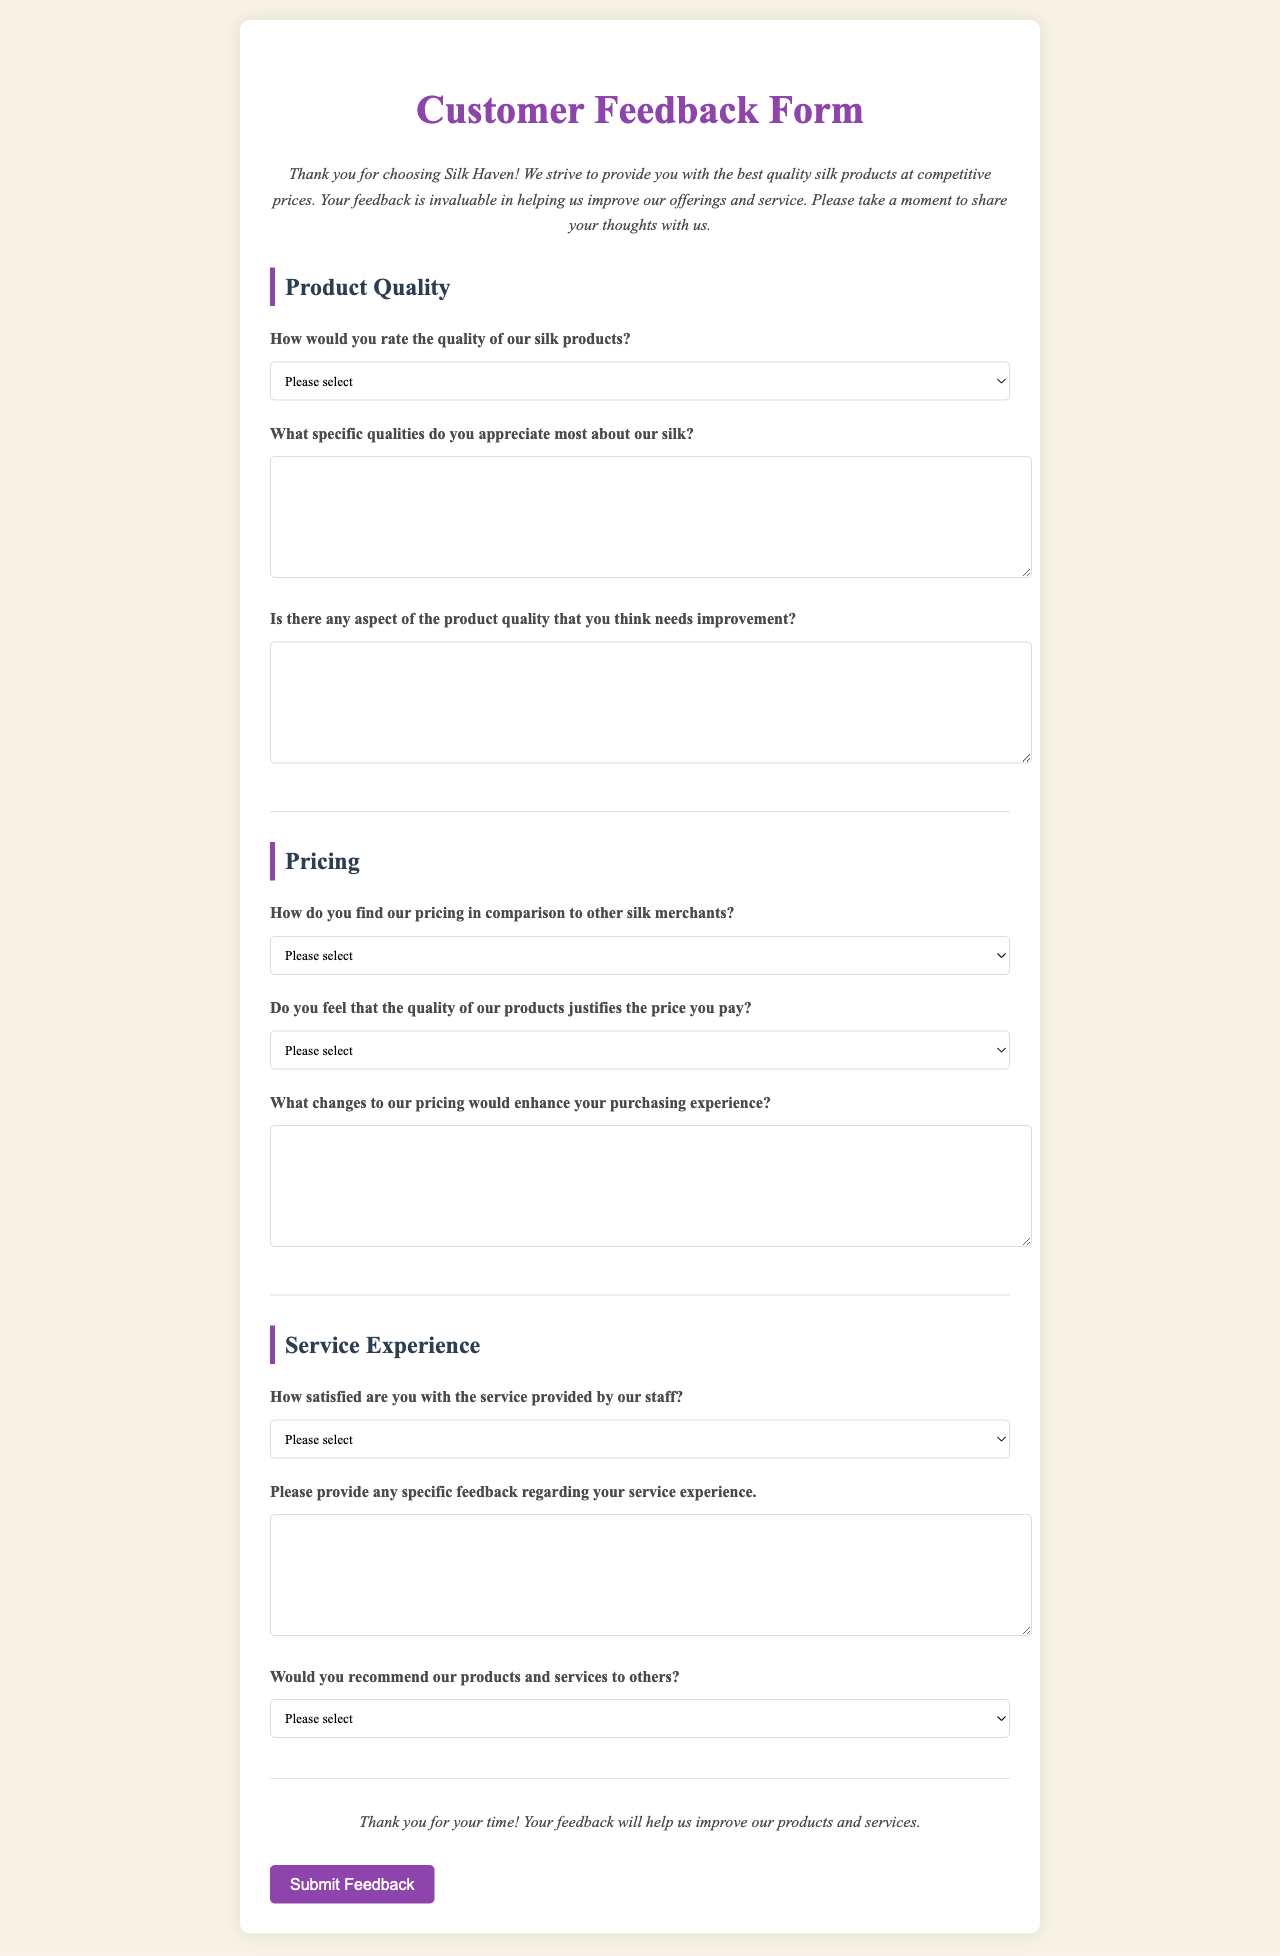What is the title of the document? The title of the document is indicated in the <title> tag within the HTML, which is "Silk Haven Customer Feedback."
Answer: Silk Haven Customer Feedback How many sections are there in the form? The sections are defined by the <div> tags with the class "section," and there are three sections: Product Quality, Pricing, and Service Experience.
Answer: 3 What does the "intro" paragraph thank customers for? The "intro" paragraph expresses gratitude for choosing Silk Haven and emphasizes the importance of customer feedback.
Answer: Choosing Silk Haven Which option is available for rating product quality? The options are provided in a <select> dropdown for rating product quality, which includes "Excellent," "Good," "Average," and "Poor."
Answer: Excellent, Good, Average, Poor How should a customer express their thoughts on pricing changes? Customers are prompted to describe their thoughts on pricing changes in a text area labeled "What changes to our pricing would enhance your purchasing experience?"
Answer: Text area for suggestions What is the purpose of the feedback form? The document clearly indicates that the purpose of the feedback form is to gather insights to improve products and services.
Answer: Improve products and services What color is the background of the form? The background color of the form is defined in CSS as a light beige color, indicated by the hex code #f8f3e6.
Answer: Light beige How does the form encourage customer participation? The form uses an introductory message and a closing note that thanks customers for their time and emphasizes the value of their feedback to encourage participation.
Answer: Thanking customers and valuing feedback What label is used for the recommendation question? The recommendation question is labeled "Would you recommend our products and services to others?" and presents several options for answers.
Answer: Would you recommend our products and services to others? 